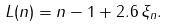<formula> <loc_0><loc_0><loc_500><loc_500>L ( n ) = n - 1 + 2 . 6 \, \xi _ { n } .</formula> 